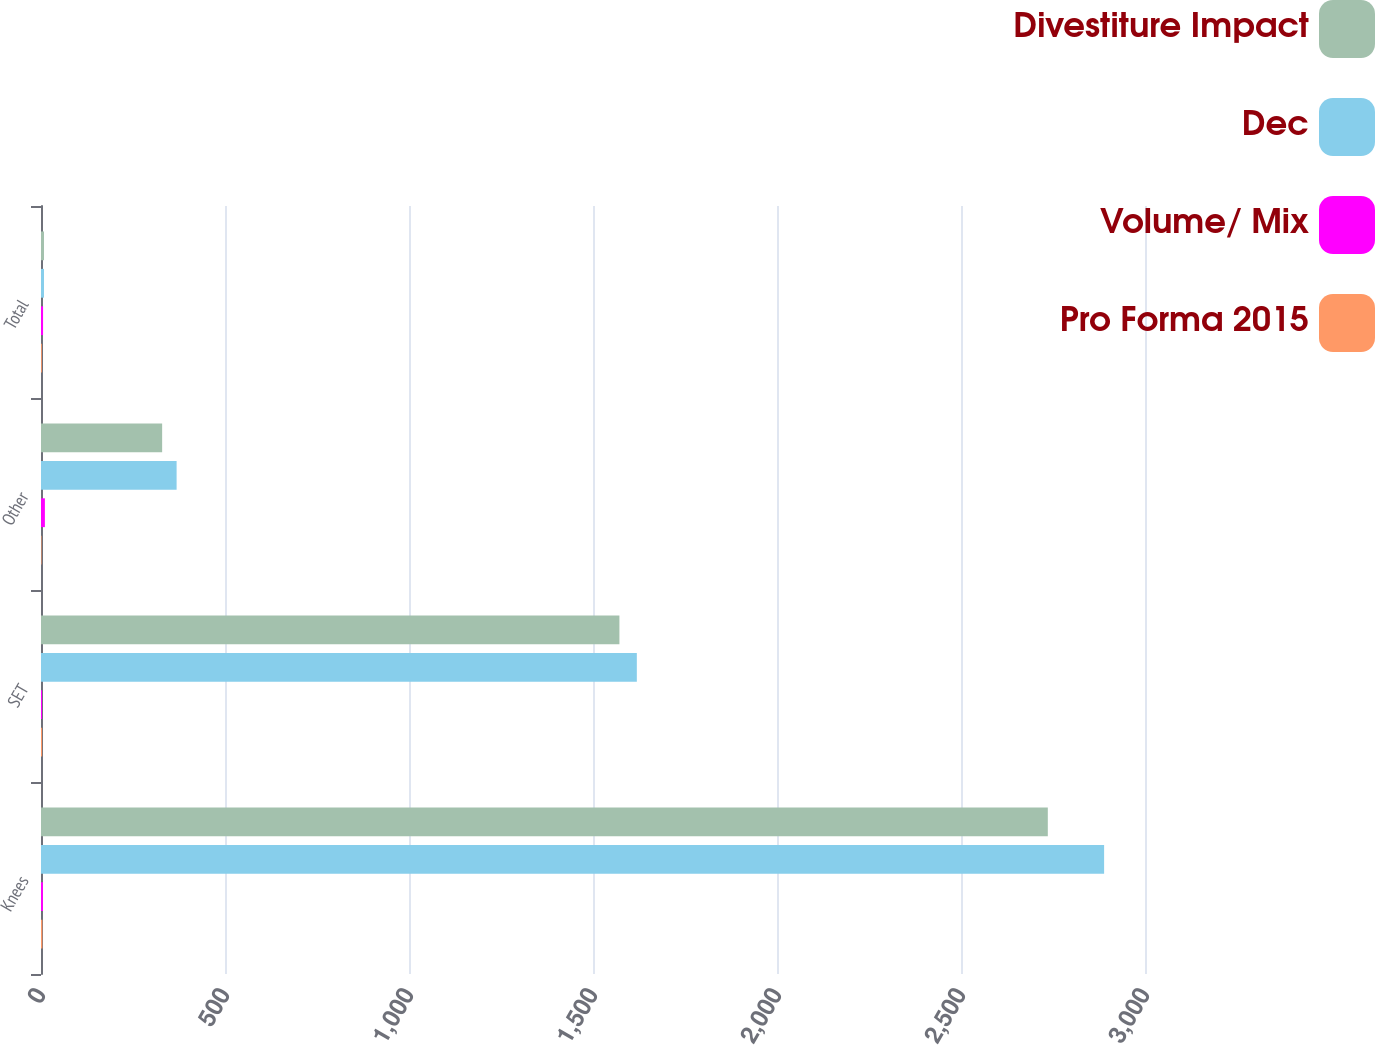<chart> <loc_0><loc_0><loc_500><loc_500><stacked_bar_chart><ecel><fcel>Knees<fcel>SET<fcel>Other<fcel>Total<nl><fcel>Divestiture Impact<fcel>2735.9<fcel>1571.8<fcel>329.2<fcel>8.1<nl><fcel>Dec<fcel>2888.9<fcel>1619.1<fcel>368.5<fcel>8.1<nl><fcel>Volume/ Mix<fcel>5.3<fcel>2.9<fcel>10.6<fcel>5.6<nl><fcel>Pro Forma 2015<fcel>3.7<fcel>3<fcel>1.4<fcel>2.3<nl></chart> 